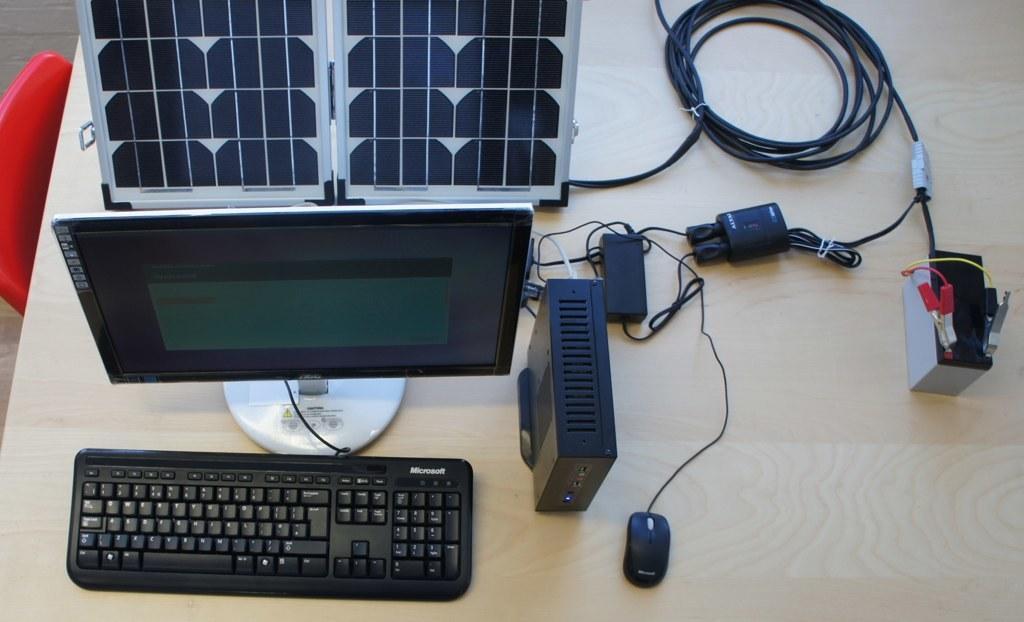Please provide a concise description of this image. In this image, There is a table which is in white color on that table there is a keyboard which is in black color and there is a monitor which is in black color, In the middle there is a black color, There is a black color mouse, There is a battery which is in white color, There is a red color chair in the left side of the image. 